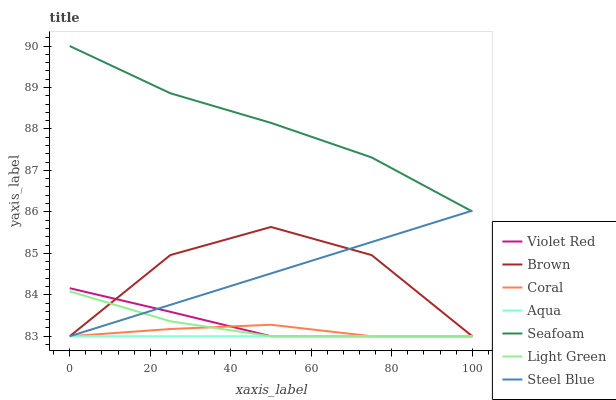Does Violet Red have the minimum area under the curve?
Answer yes or no. No. Does Violet Red have the maximum area under the curve?
Answer yes or no. No. Is Violet Red the smoothest?
Answer yes or no. No. Is Violet Red the roughest?
Answer yes or no. No. Does Seafoam have the lowest value?
Answer yes or no. No. Does Violet Red have the highest value?
Answer yes or no. No. Is Violet Red less than Seafoam?
Answer yes or no. Yes. Is Seafoam greater than Brown?
Answer yes or no. Yes. Does Violet Red intersect Seafoam?
Answer yes or no. No. 